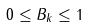Convert formula to latex. <formula><loc_0><loc_0><loc_500><loc_500>0 \leq B _ { k } \leq 1</formula> 